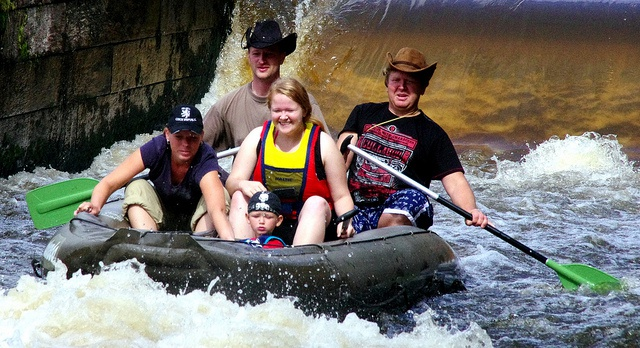Describe the objects in this image and their specific colors. I can see boat in darkgreen, black, gray, and darkgray tones, people in darkgreen, black, maroon, brown, and lightpink tones, people in darkgreen, white, black, lightpink, and brown tones, people in darkgreen, black, tan, lightgray, and darkgray tones, and people in darkgreen, black, darkgray, and gray tones in this image. 